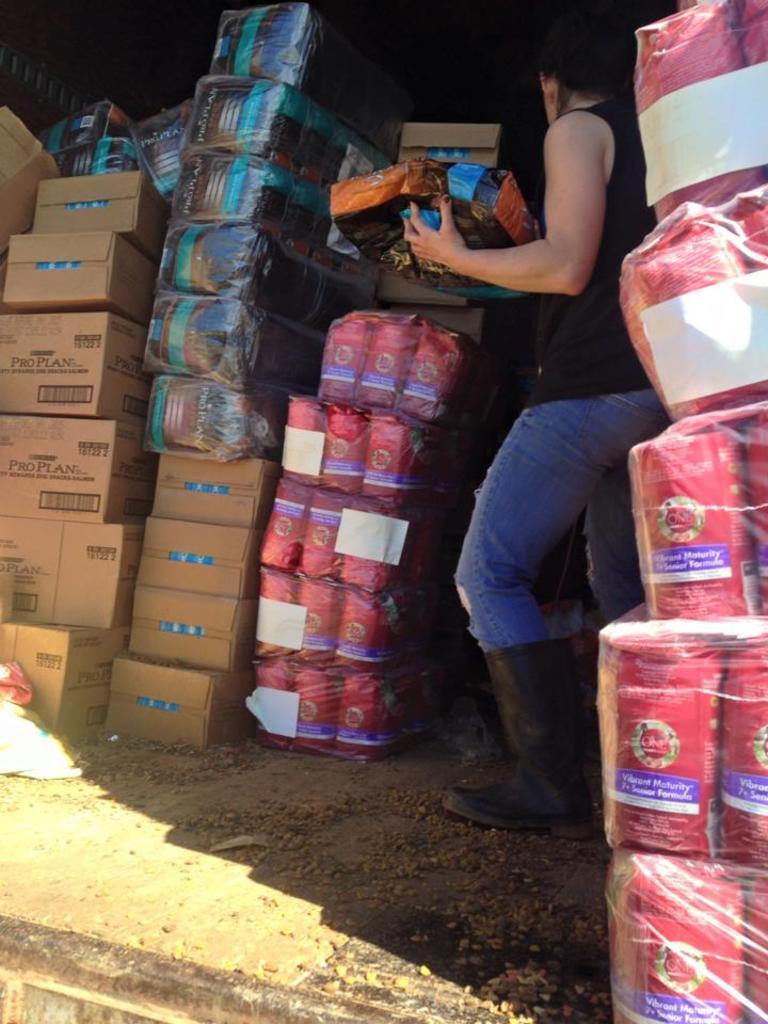Can you describe this image briefly? In this image I can see a person standing in the middle of parcel boxes. 